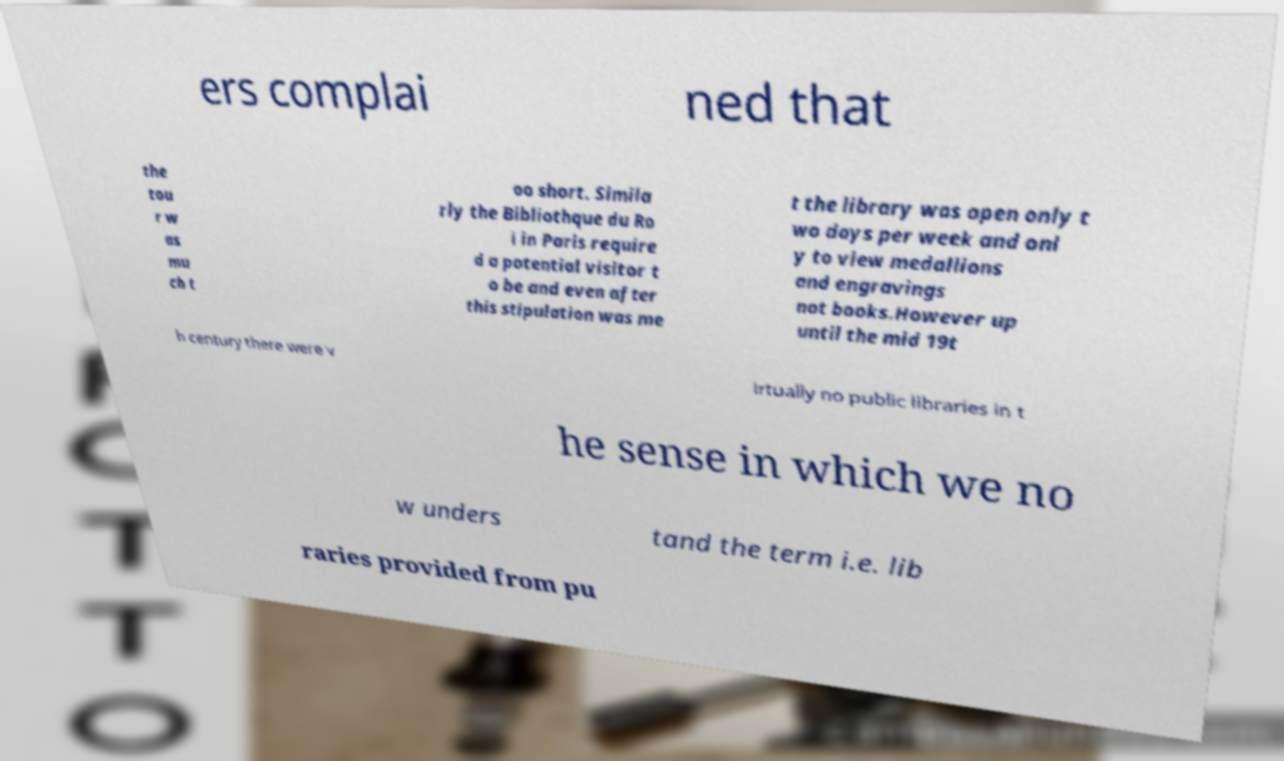There's text embedded in this image that I need extracted. Can you transcribe it verbatim? ers complai ned that the tou r w as mu ch t oo short. Simila rly the Bibliothque du Ro i in Paris require d a potential visitor t o be and even after this stipulation was me t the library was open only t wo days per week and onl y to view medallions and engravings not books.However up until the mid 19t h century there were v irtually no public libraries in t he sense in which we no w unders tand the term i.e. lib raries provided from pu 